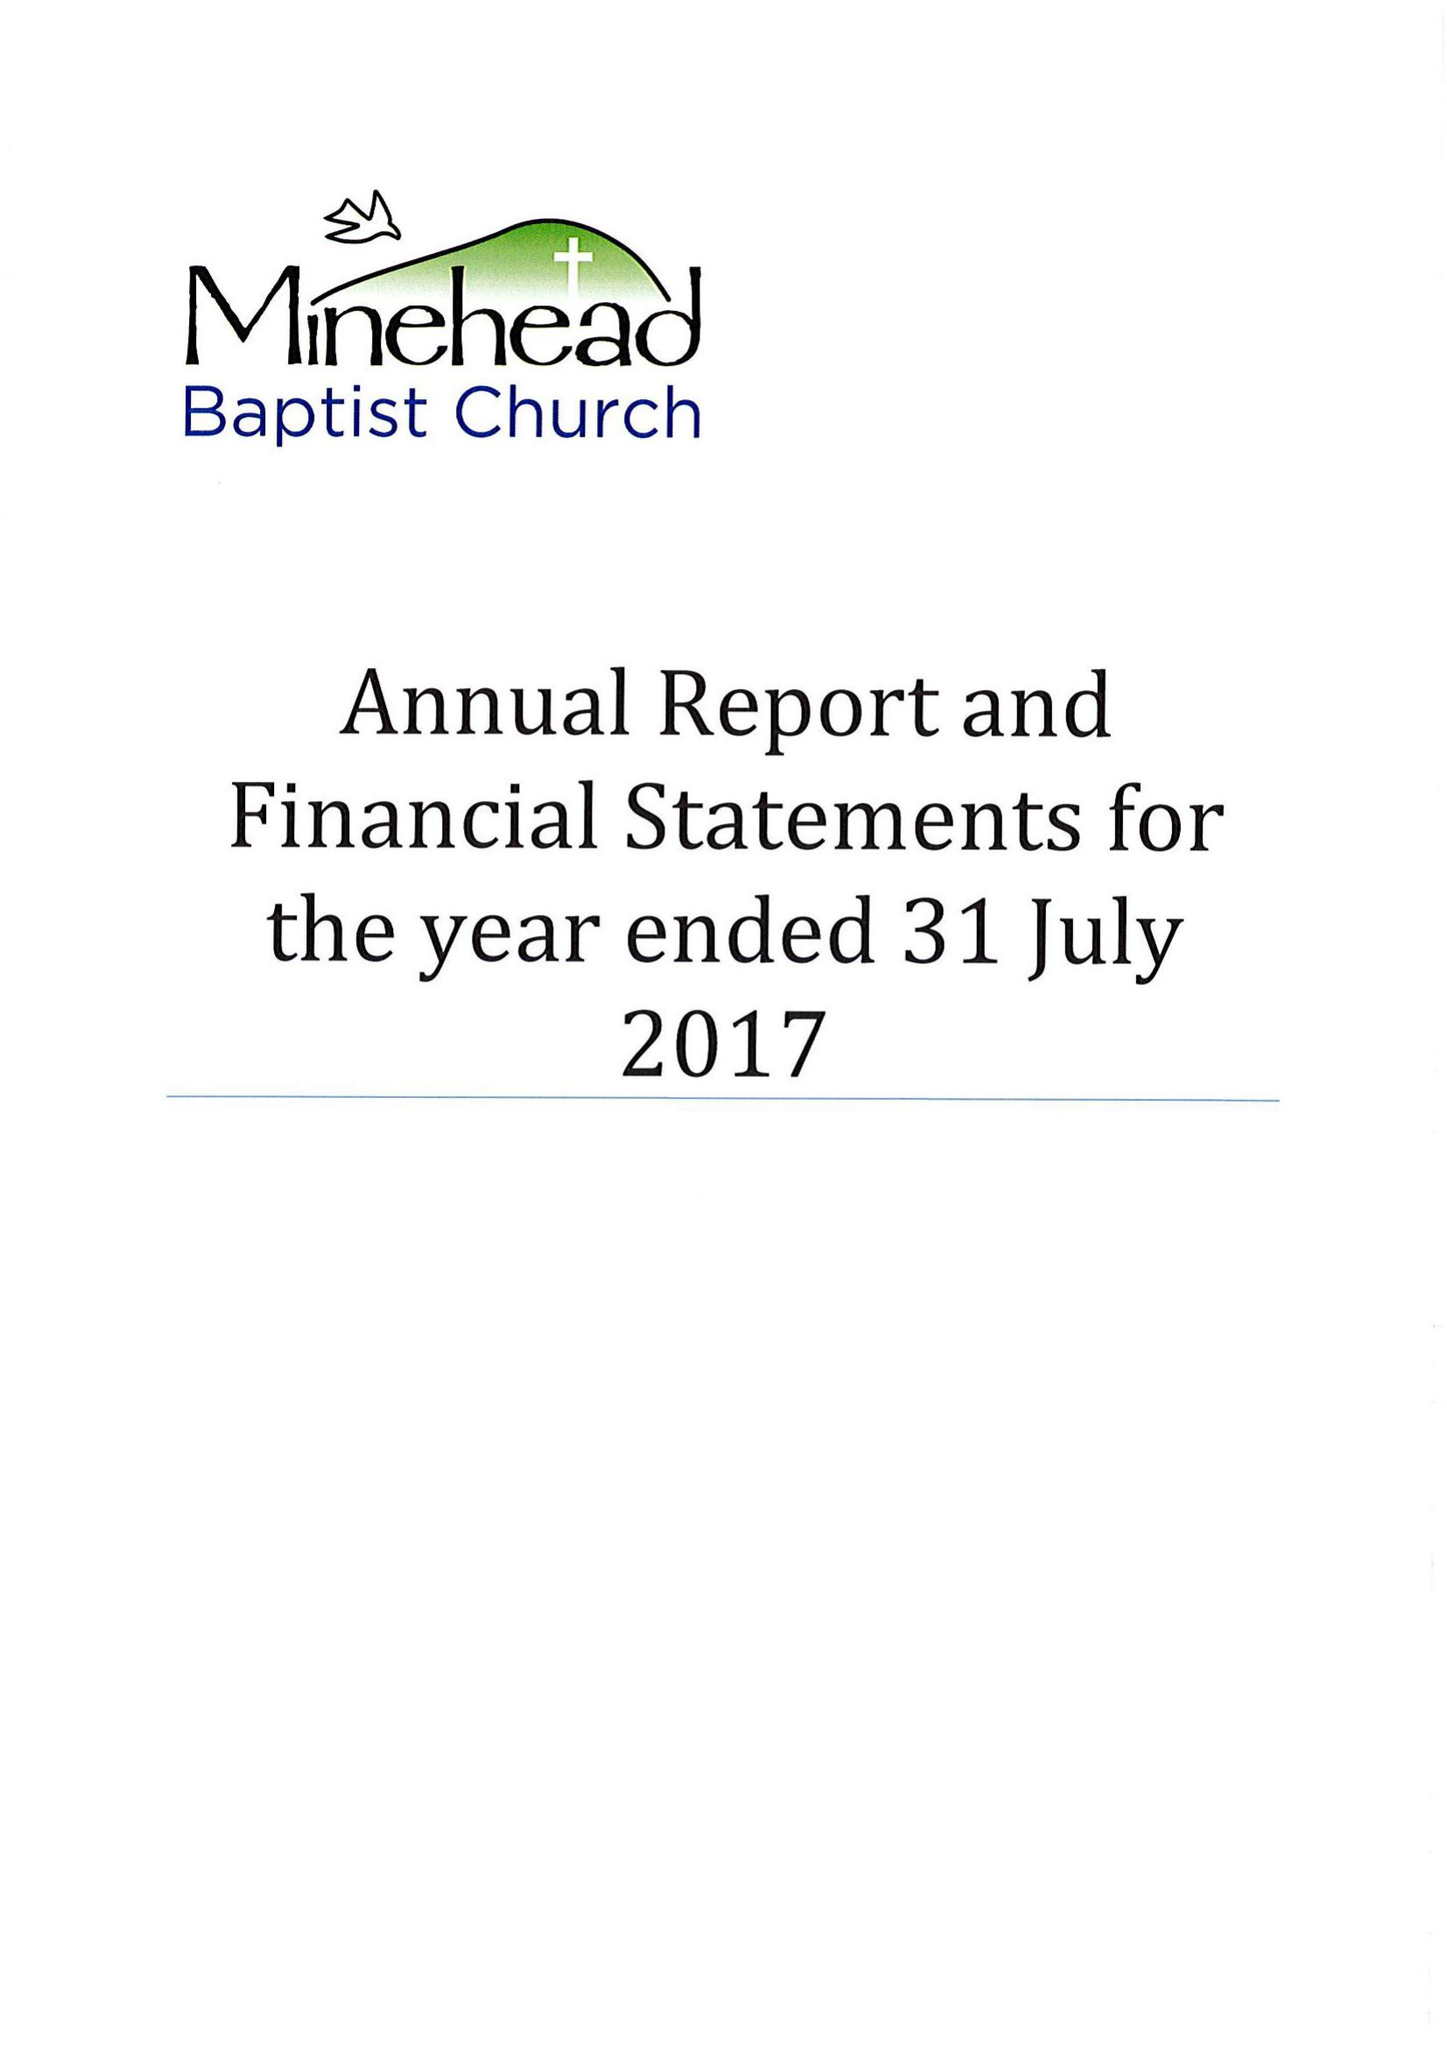What is the value for the address__street_line?
Answer the question using a single word or phrase. PARKS LANE 